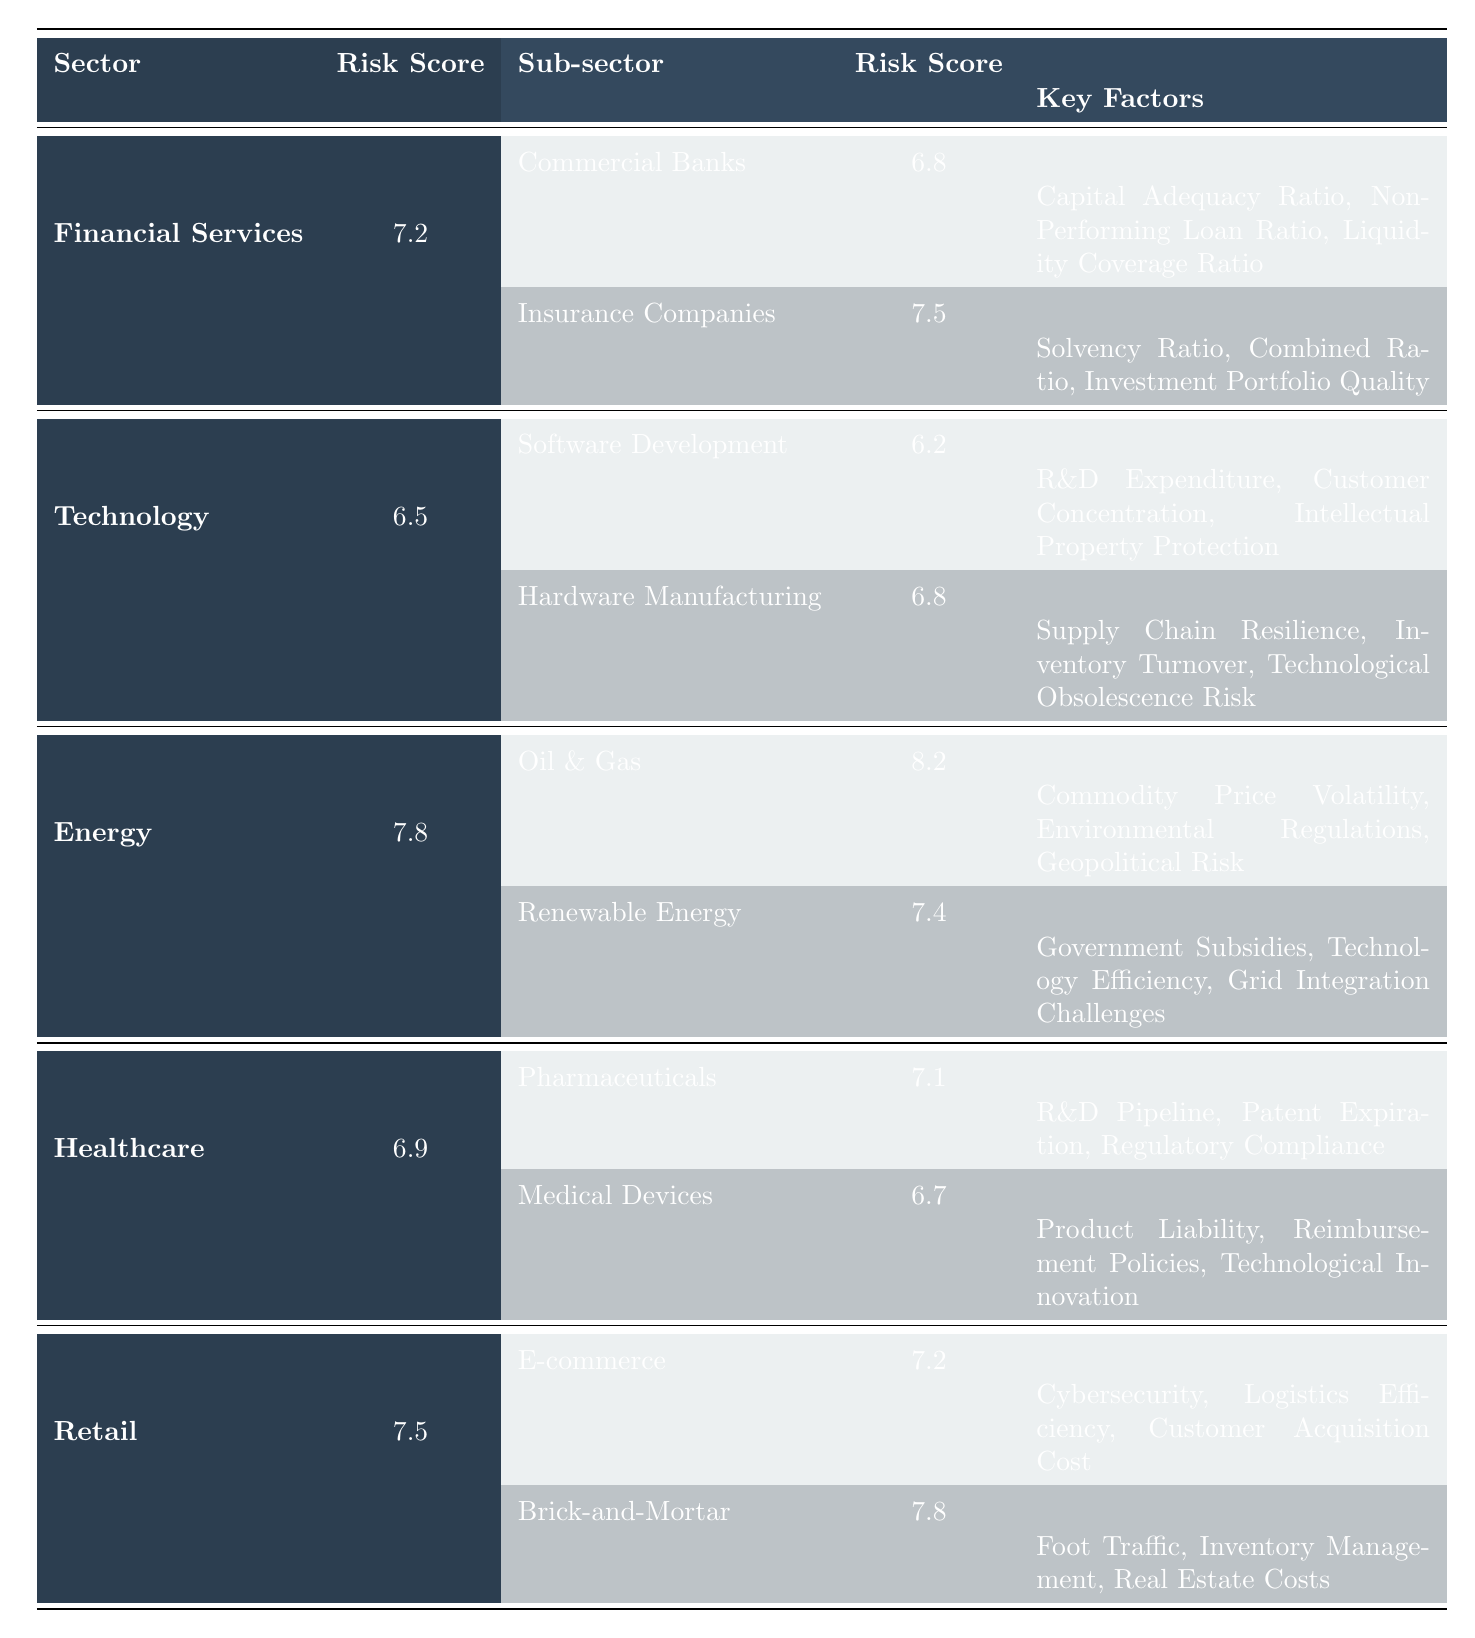What is the Overall Risk Score for the Energy sector? The Overall Risk Score for the Energy sector is listed directly in the table. It shows a value of 7.8.
Answer: 7.8 Which sub-sector of Financial Services has the highest Risk Score? In the Financial Services sector, the sub-sectors are Commercial Banks with a Risk Score of 6.8 and Insurance Companies with a Risk Score of 7.5. Comparing these, Insurance Companies has the higher score.
Answer: Insurance Companies What are the Key Factors for Healthcare Pharmaceuticals? The Key Factors for the Pharmaceuticals sub-sector are explicitly outlined in the table as R&D Pipeline, Patent Expiration, and Regulatory Compliance.
Answer: R&D Pipeline, Patent Expiration, Regulatory Compliance Calculate the average Risk Score of the sub-sectors under the Retail sector. The sub-sectors listed under Retail are E-commerce (7.2) and Brick-and-Mortar (7.8). Their average is calculated as (7.2 + 7.8) / 2 = 7.5.
Answer: 7.5 Is the Overall Risk Score for the Technology sector greater than that of Retail? The Overall Risk Score for Technology is 6.5, while for Retail it is 7.5. Since 6.5 is less than 7.5, the statement is false.
Answer: No Which sector has the highest sub-sector Risk Score? Comparing the highest sub-sector Risk Scores: Oil & Gas (8.2), Insurance Companies (7.5), Hardware Manufacturing (6.8), Pharmaceuticals (7.1), and both Retail sub-sectors (7.2 and 7.8), it is clear that Oil & Gas has the highest value of 8.2.
Answer: Oil & Gas What is the difference between the Overall Risk Scores of the Energy and Financial Services sectors? The Overall Risk Score for Energy is 7.8, and for Financial Services, it is 7.2. The difference is calculated as 7.8 - 7.2 = 0.6.
Answer: 0.6 Identify the sub-sector under Technology with the lowest Risk Score. In the Technology sector, Software Development has a Risk Score of 6.2 and Hardware Manufacturing has 6.8. Therefore, Software Development has the lowest score.
Answer: Software Development Which sector exhibits the highest Overall Risk Score and what is that score? The Overall Risk Score for Energy is 7.8, while for the other sectors, the scores are lower (Financial Services 7.2, Technology 6.5, Healthcare 6.9, Retail 7.5). Energy has the highest score.
Answer: Energy, 7.8 What is the total number of Key Factors listed for the sub-sectors in the Healthcare sector? The Healthcare sector has Pharmaceuticals with 3 Key Factors and Medical Devices with 3 Key Factors, totaling 6 Key Factors across both sub-sectors.
Answer: 6 